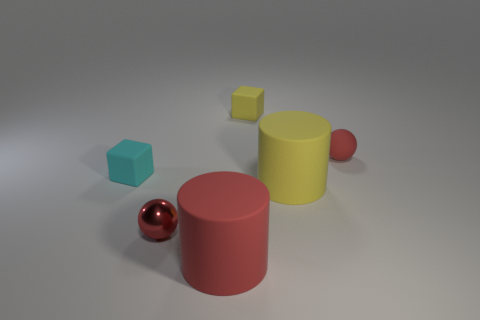Is the color of the small matte sphere the same as the ball in front of the cyan rubber thing?
Your response must be concise. Yes. There is a matte cylinder that is the same color as the small metallic sphere; what size is it?
Provide a short and direct response. Large. How many yellow rubber objects have the same size as the shiny thing?
Your answer should be compact. 1. There is a ball left of the block behind the rubber sphere; how many cubes are left of it?
Keep it short and to the point. 1. Are there the same number of yellow cylinders right of the yellow cylinder and small yellow objects that are in front of the tiny yellow rubber object?
Your answer should be very brief. Yes. How many tiny metal things have the same shape as the small red matte object?
Make the answer very short. 1. Are there any spheres made of the same material as the red cylinder?
Keep it short and to the point. Yes. What shape is the big thing that is the same color as the small metal sphere?
Make the answer very short. Cylinder. What number of small rubber cubes are there?
Offer a terse response. 2. How many cylinders are either cyan objects or tiny red rubber things?
Provide a succinct answer. 0. 